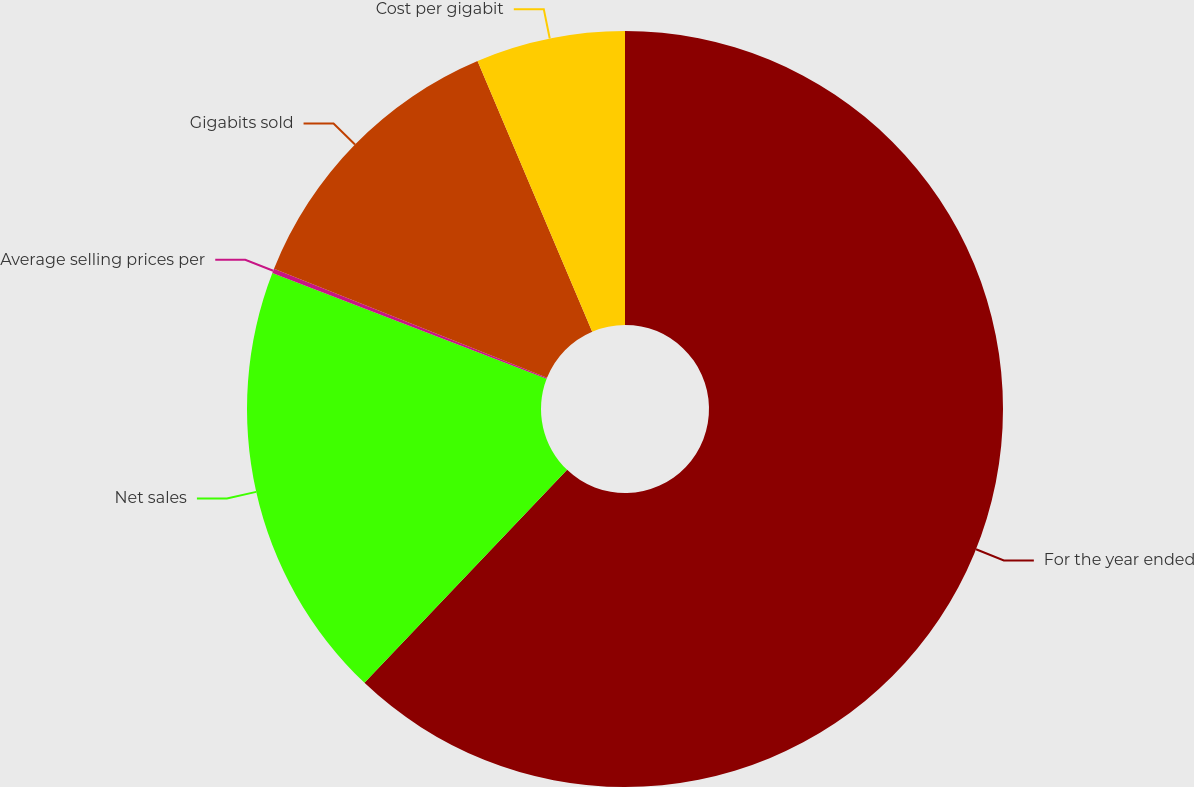<chart> <loc_0><loc_0><loc_500><loc_500><pie_chart><fcel>For the year ended<fcel>Net sales<fcel>Average selling prices per<fcel>Gigabits sold<fcel>Cost per gigabit<nl><fcel>62.11%<fcel>18.76%<fcel>0.19%<fcel>12.57%<fcel>6.38%<nl></chart> 